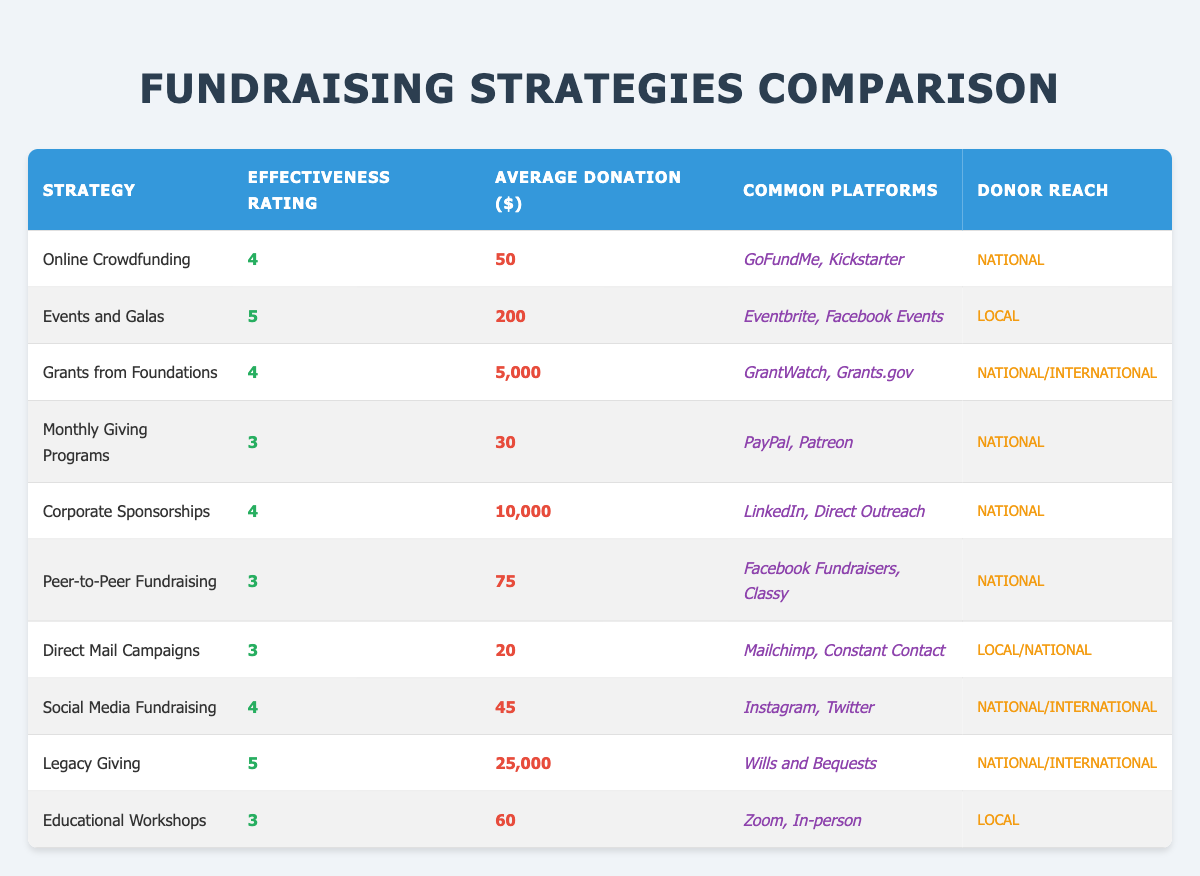What is the effectiveness rating for "Corporate Sponsorships"? The effectiveness rating is explicitly listed in the table under the "Effectiveness Rating" column corresponding to the strategy "Corporate Sponsorships." It is noted as 4.
Answer: 4 Which fundraising strategy has the highest average donation? To determine this, we compare the "Average Donation ($)" values for each strategy in the table. The "Legacy Giving" strategy has the highest average donation at 25,000 dollars.
Answer: 25,000 Is the average donation for "Online Crowdfunding" higher than "Social Media Fundraising"? We compare the "Average Donation ($)" values: "Online Crowdfunding" is 50 dollars and "Social Media Fundraising" is 45 dollars. Since 50 is greater than 45, the statement is true.
Answer: Yes What is the average effectiveness rating of the fundraising strategies listed? First, we sum the effectiveness ratings from all listed strategies: (4 + 5 + 4 + 3 + 4 + 3 + 3 + 4 + 5 + 3) = 43. There are 10 strategies, so we divide by 10 to find the average: 43 / 10 = 4.3.
Answer: 4.3 How many strategies have an effectiveness rating of 5? By reviewing the "Effectiveness Rating" column, we identify the strategies rated 5: "Events and Galas" and "Legacy Giving." There are a total of 2 strategies with an effectiveness rating of 5.
Answer: 2 Which fundraising strategy has both a high effectiveness rating and a substantial average donation? We look for strategies with an effectiveness rating of 4 or 5 and then review their average donations. "Grants from Foundations" (effectiveness 4, average 5,000), "Corporate Sponsorships" (effectiveness 4, average 10,000), "Events and Galas" (effectiveness 5, average 200), and "Legacy Giving" (effectiveness 5, average 25,000) all fit this criteria. The one with the highest average donation is "Legacy Giving."
Answer: Legacy Giving Is "Monthly Giving Programs" more effective than "Peer-to-Peer Fundraising"? We compare their effectiveness ratings: "Monthly Giving Programs" has a rating of 3, while "Peer-to-Peer Fundraising" also has a rating of 3. They are equal in effectiveness, so the answer is false.
Answer: No What is the total donation amount from "Events and Galas" and "Legacy Giving"? We take the average donations of both strategies: "Events and Galas" average is 200 and "Legacy Giving" average is 25,000. Thus, the total is 200 + 25,000 = 25,200 dollars.
Answer: 25,200 How many strategies allow for local donor reach? We check the "Donor Reach" column for strategies marked "Local." The strategies fitting this are "Events and Galas," "Direct Mail Campaigns," and "Educational Workshops." Thus, there are 3 strategies with local donor reach.
Answer: 3 